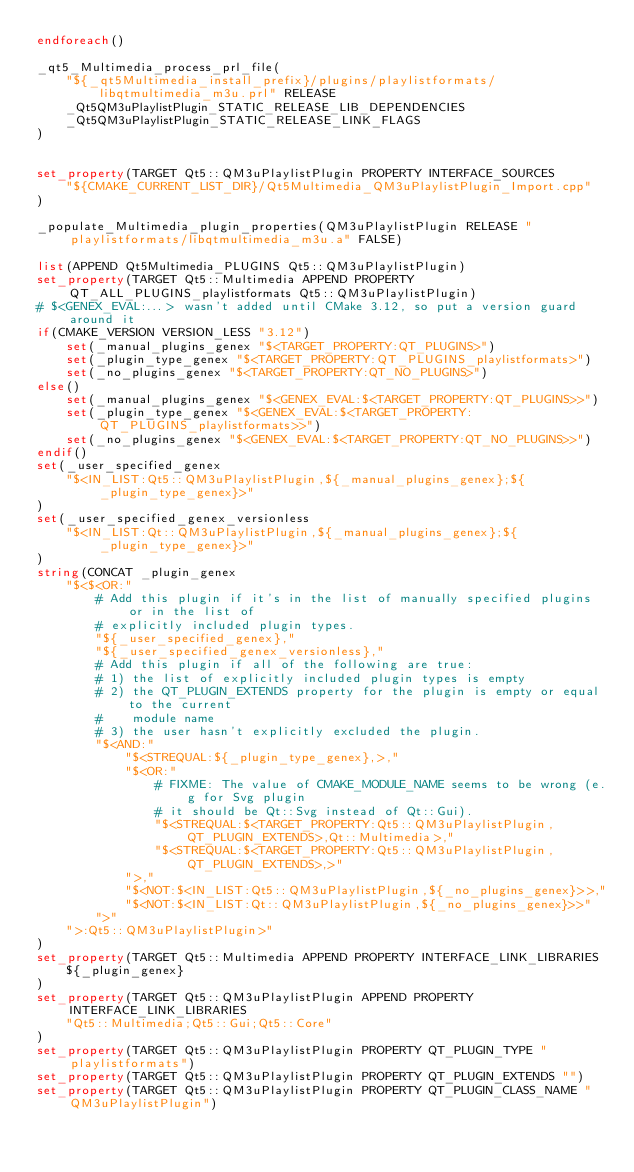Convert code to text. <code><loc_0><loc_0><loc_500><loc_500><_CMake_>endforeach()

_qt5_Multimedia_process_prl_file(
    "${_qt5Multimedia_install_prefix}/plugins/playlistformats/libqtmultimedia_m3u.prl" RELEASE
    _Qt5QM3uPlaylistPlugin_STATIC_RELEASE_LIB_DEPENDENCIES
    _Qt5QM3uPlaylistPlugin_STATIC_RELEASE_LINK_FLAGS
)


set_property(TARGET Qt5::QM3uPlaylistPlugin PROPERTY INTERFACE_SOURCES
    "${CMAKE_CURRENT_LIST_DIR}/Qt5Multimedia_QM3uPlaylistPlugin_Import.cpp"
)

_populate_Multimedia_plugin_properties(QM3uPlaylistPlugin RELEASE "playlistformats/libqtmultimedia_m3u.a" FALSE)

list(APPEND Qt5Multimedia_PLUGINS Qt5::QM3uPlaylistPlugin)
set_property(TARGET Qt5::Multimedia APPEND PROPERTY QT_ALL_PLUGINS_playlistformats Qt5::QM3uPlaylistPlugin)
# $<GENEX_EVAL:...> wasn't added until CMake 3.12, so put a version guard around it
if(CMAKE_VERSION VERSION_LESS "3.12")
    set(_manual_plugins_genex "$<TARGET_PROPERTY:QT_PLUGINS>")
    set(_plugin_type_genex "$<TARGET_PROPERTY:QT_PLUGINS_playlistformats>")
    set(_no_plugins_genex "$<TARGET_PROPERTY:QT_NO_PLUGINS>")
else()
    set(_manual_plugins_genex "$<GENEX_EVAL:$<TARGET_PROPERTY:QT_PLUGINS>>")
    set(_plugin_type_genex "$<GENEX_EVAL:$<TARGET_PROPERTY:QT_PLUGINS_playlistformats>>")
    set(_no_plugins_genex "$<GENEX_EVAL:$<TARGET_PROPERTY:QT_NO_PLUGINS>>")
endif()
set(_user_specified_genex
    "$<IN_LIST:Qt5::QM3uPlaylistPlugin,${_manual_plugins_genex};${_plugin_type_genex}>"
)
set(_user_specified_genex_versionless
    "$<IN_LIST:Qt::QM3uPlaylistPlugin,${_manual_plugins_genex};${_plugin_type_genex}>"
)
string(CONCAT _plugin_genex
    "$<$<OR:"
        # Add this plugin if it's in the list of manually specified plugins or in the list of
        # explicitly included plugin types.
        "${_user_specified_genex},"
        "${_user_specified_genex_versionless},"
        # Add this plugin if all of the following are true:
        # 1) the list of explicitly included plugin types is empty
        # 2) the QT_PLUGIN_EXTENDS property for the plugin is empty or equal to the current
        #    module name
        # 3) the user hasn't explicitly excluded the plugin.
        "$<AND:"
            "$<STREQUAL:${_plugin_type_genex},>,"
            "$<OR:"
                # FIXME: The value of CMAKE_MODULE_NAME seems to be wrong (e.g for Svg plugin
                # it should be Qt::Svg instead of Qt::Gui).
                "$<STREQUAL:$<TARGET_PROPERTY:Qt5::QM3uPlaylistPlugin,QT_PLUGIN_EXTENDS>,Qt::Multimedia>,"
                "$<STREQUAL:$<TARGET_PROPERTY:Qt5::QM3uPlaylistPlugin,QT_PLUGIN_EXTENDS>,>"
            ">,"
            "$<NOT:$<IN_LIST:Qt5::QM3uPlaylistPlugin,${_no_plugins_genex}>>,"
            "$<NOT:$<IN_LIST:Qt::QM3uPlaylistPlugin,${_no_plugins_genex}>>"
        ">"
    ">:Qt5::QM3uPlaylistPlugin>"
)
set_property(TARGET Qt5::Multimedia APPEND PROPERTY INTERFACE_LINK_LIBRARIES
    ${_plugin_genex}
)
set_property(TARGET Qt5::QM3uPlaylistPlugin APPEND PROPERTY INTERFACE_LINK_LIBRARIES
    "Qt5::Multimedia;Qt5::Gui;Qt5::Core"
)
set_property(TARGET Qt5::QM3uPlaylistPlugin PROPERTY QT_PLUGIN_TYPE "playlistformats")
set_property(TARGET Qt5::QM3uPlaylistPlugin PROPERTY QT_PLUGIN_EXTENDS "")
set_property(TARGET Qt5::QM3uPlaylistPlugin PROPERTY QT_PLUGIN_CLASS_NAME "QM3uPlaylistPlugin")
</code> 